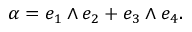Convert formula to latex. <formula><loc_0><loc_0><loc_500><loc_500>\alpha = e _ { 1 } \wedge e _ { 2 } + e _ { 3 } \wedge e _ { 4 } .</formula> 